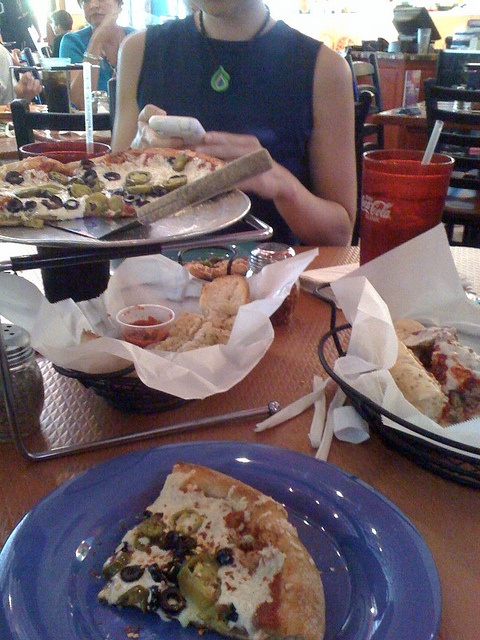Describe the objects in this image and their specific colors. I can see dining table in gray, darkgray, black, and maroon tones, people in gray, navy, and black tones, pizza in gray, black, and maroon tones, pizza in gray, darkgray, and tan tones, and cup in gray, maroon, and brown tones in this image. 